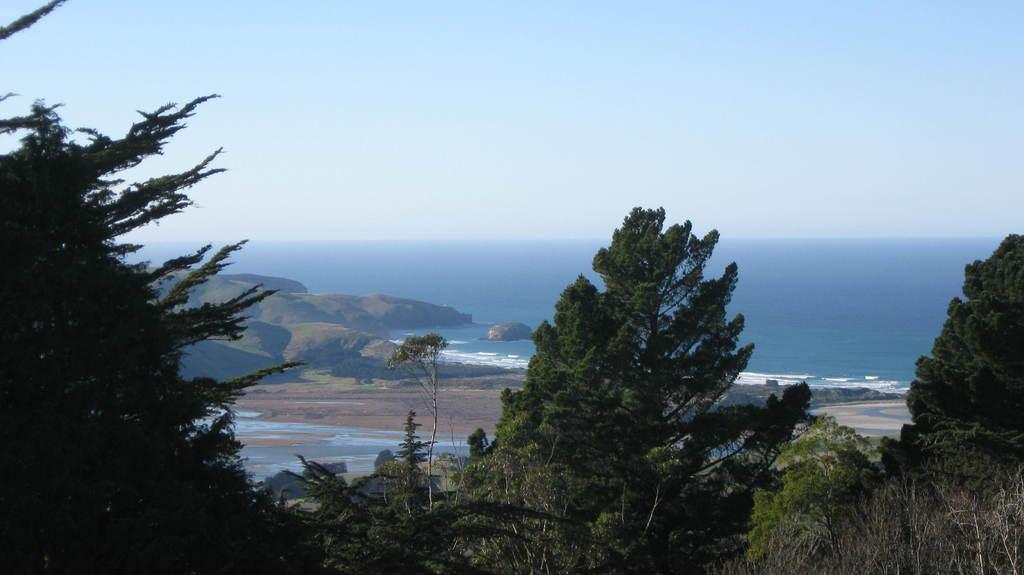What type of vegetation can be seen in the image? There are trees in the image. What geographical feature is present in the image? There is a hill in the image. What natural element is visible in the image? Water is visible in the image. What part of the natural environment is visible in the image? The ground is visible in the image. What part of the sky is visible in the image? The sky is visible in the image. How many spiders are crawling on the hill in the image? There are no spiders visible in the image; it features trees, a hill, water, the ground, and the sky. What type of mask is being worn by the trees in the image? There are no masks present in the image, as it features trees, a hill, water, the ground, and the sky. 